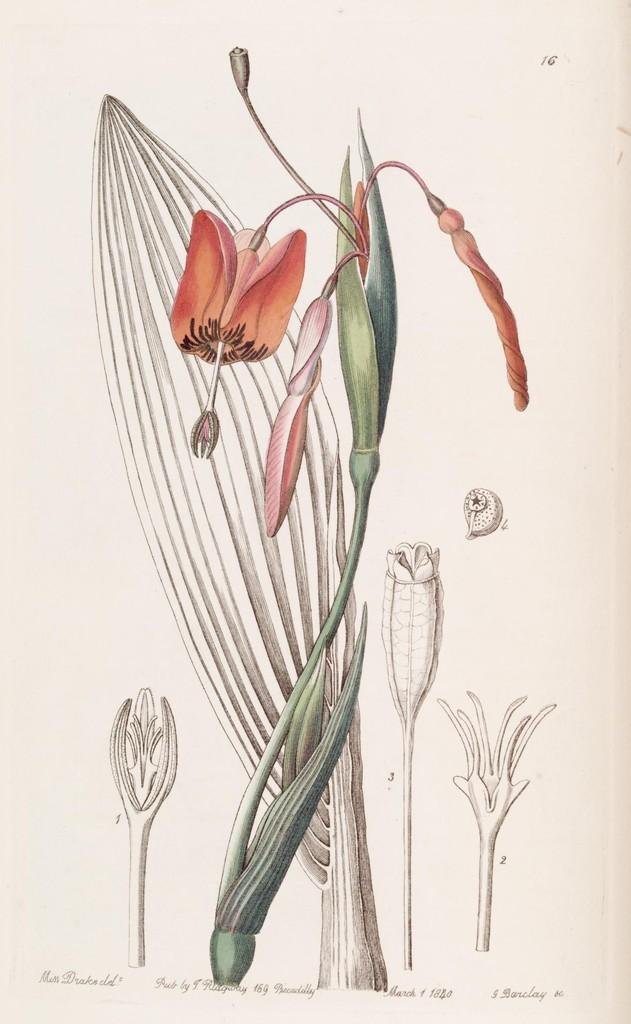What is present on the paper in the image? The paper has a tree painting on it. Is there any text on the paper? Yes, there is text on the paper. What type of jam is spread on the rose in the image? There is no jam or rose present in the image; it only features a paper with a tree painting and text. 